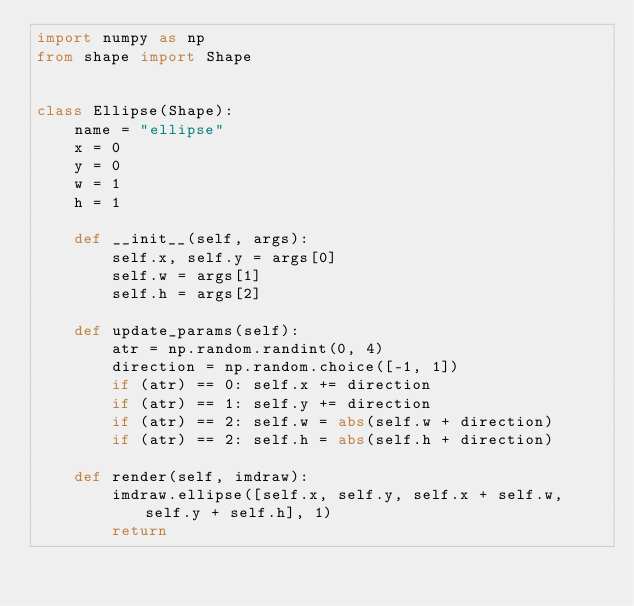Convert code to text. <code><loc_0><loc_0><loc_500><loc_500><_Python_>import numpy as np
from shape import Shape


class Ellipse(Shape):
    name = "ellipse"
    x = 0
    y = 0
    w = 1
    h = 1
    
    def __init__(self, args):
        self.x, self.y = args[0]
        self.w = args[1]
        self.h = args[2]

    def update_params(self):
        atr = np.random.randint(0, 4)
        direction = np.random.choice([-1, 1])
        if (atr) == 0: self.x += direction
        if (atr) == 1: self.y += direction
        if (atr) == 2: self.w = abs(self.w + direction)
        if (atr) == 2: self.h = abs(self.h + direction)

    def render(self, imdraw):
        imdraw.ellipse([self.x, self.y, self.x + self.w, self.y + self.h], 1)
        return</code> 